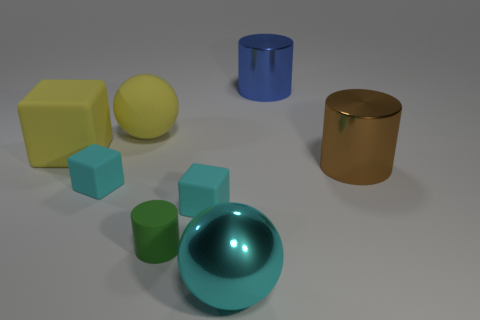Add 2 large yellow metallic cylinders. How many objects exist? 10 Subtract all spheres. How many objects are left? 6 Subtract 0 blue balls. How many objects are left? 8 Subtract all blue cylinders. Subtract all green rubber cylinders. How many objects are left? 6 Add 1 large blue shiny cylinders. How many large blue shiny cylinders are left? 2 Add 7 big brown metallic cylinders. How many big brown metallic cylinders exist? 8 